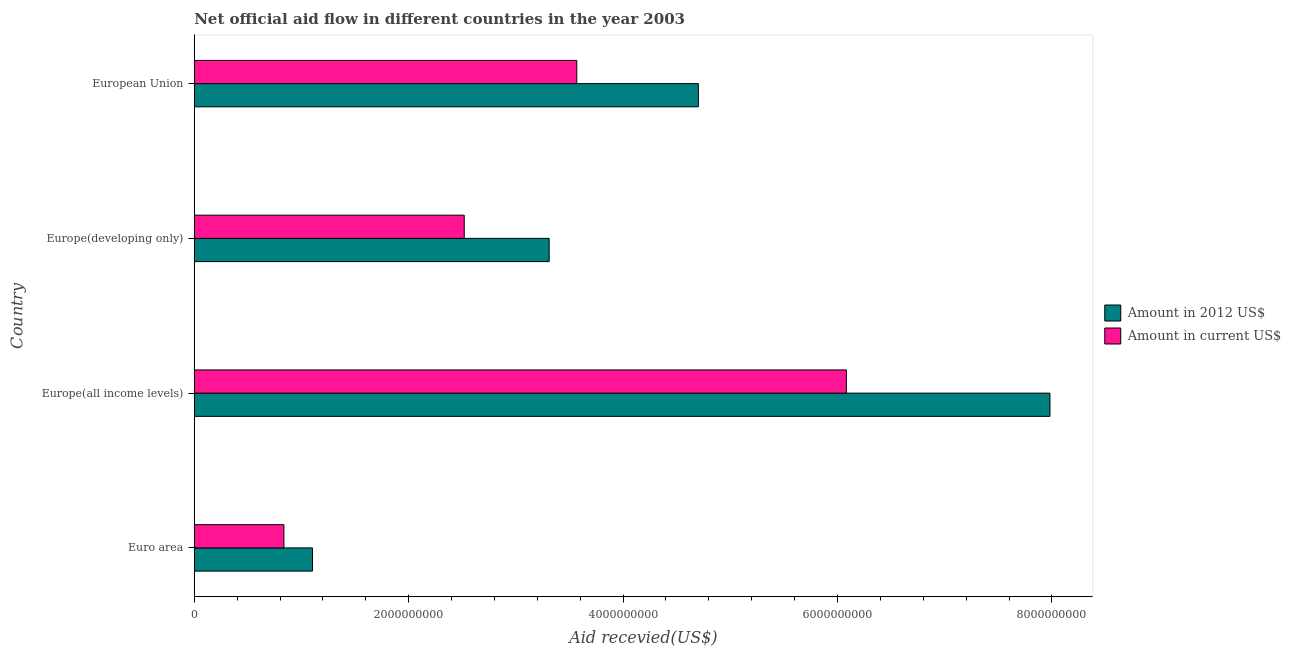How many bars are there on the 1st tick from the top?
Ensure brevity in your answer.  2. What is the label of the 3rd group of bars from the top?
Your answer should be very brief. Europe(all income levels). In how many cases, is the number of bars for a given country not equal to the number of legend labels?
Make the answer very short. 0. What is the amount of aid received(expressed in us$) in Euro area?
Your response must be concise. 8.36e+08. Across all countries, what is the maximum amount of aid received(expressed in 2012 us$)?
Your answer should be very brief. 7.98e+09. Across all countries, what is the minimum amount of aid received(expressed in 2012 us$)?
Ensure brevity in your answer.  1.10e+09. In which country was the amount of aid received(expressed in 2012 us$) maximum?
Provide a short and direct response. Europe(all income levels). In which country was the amount of aid received(expressed in 2012 us$) minimum?
Offer a very short reply. Euro area. What is the total amount of aid received(expressed in 2012 us$) in the graph?
Your answer should be very brief. 1.71e+1. What is the difference between the amount of aid received(expressed in 2012 us$) in Europe(developing only) and that in European Union?
Make the answer very short. -1.39e+09. What is the difference between the amount of aid received(expressed in us$) in Europe(all income levels) and the amount of aid received(expressed in 2012 us$) in European Union?
Ensure brevity in your answer.  1.38e+09. What is the average amount of aid received(expressed in 2012 us$) per country?
Make the answer very short. 4.27e+09. What is the difference between the amount of aid received(expressed in us$) and amount of aid received(expressed in 2012 us$) in European Union?
Provide a short and direct response. -1.13e+09. In how many countries, is the amount of aid received(expressed in 2012 us$) greater than 800000000 US$?
Provide a short and direct response. 4. What is the ratio of the amount of aid received(expressed in us$) in Europe(all income levels) to that in Europe(developing only)?
Your response must be concise. 2.42. What is the difference between the highest and the second highest amount of aid received(expressed in us$)?
Provide a succinct answer. 2.51e+09. What is the difference between the highest and the lowest amount of aid received(expressed in 2012 us$)?
Offer a very short reply. 6.88e+09. What does the 1st bar from the top in Euro area represents?
Make the answer very short. Amount in current US$. What does the 2nd bar from the bottom in Euro area represents?
Your answer should be very brief. Amount in current US$. Does the graph contain any zero values?
Offer a terse response. No. What is the title of the graph?
Ensure brevity in your answer.  Net official aid flow in different countries in the year 2003. Does "International Tourists" appear as one of the legend labels in the graph?
Your response must be concise. No. What is the label or title of the X-axis?
Your answer should be very brief. Aid recevied(US$). What is the Aid recevied(US$) in Amount in 2012 US$ in Euro area?
Your answer should be very brief. 1.10e+09. What is the Aid recevied(US$) of Amount in current US$ in Euro area?
Your answer should be very brief. 8.36e+08. What is the Aid recevied(US$) in Amount in 2012 US$ in Europe(all income levels)?
Keep it short and to the point. 7.98e+09. What is the Aid recevied(US$) of Amount in current US$ in Europe(all income levels)?
Offer a terse response. 6.08e+09. What is the Aid recevied(US$) in Amount in 2012 US$ in Europe(developing only)?
Offer a terse response. 3.31e+09. What is the Aid recevied(US$) in Amount in current US$ in Europe(developing only)?
Ensure brevity in your answer.  2.52e+09. What is the Aid recevied(US$) of Amount in 2012 US$ in European Union?
Give a very brief answer. 4.70e+09. What is the Aid recevied(US$) in Amount in current US$ in European Union?
Your answer should be compact. 3.57e+09. Across all countries, what is the maximum Aid recevied(US$) in Amount in 2012 US$?
Provide a succinct answer. 7.98e+09. Across all countries, what is the maximum Aid recevied(US$) in Amount in current US$?
Provide a succinct answer. 6.08e+09. Across all countries, what is the minimum Aid recevied(US$) of Amount in 2012 US$?
Offer a terse response. 1.10e+09. Across all countries, what is the minimum Aid recevied(US$) of Amount in current US$?
Offer a terse response. 8.36e+08. What is the total Aid recevied(US$) of Amount in 2012 US$ in the graph?
Offer a terse response. 1.71e+1. What is the total Aid recevied(US$) of Amount in current US$ in the graph?
Your answer should be very brief. 1.30e+1. What is the difference between the Aid recevied(US$) of Amount in 2012 US$ in Euro area and that in Europe(all income levels)?
Keep it short and to the point. -6.88e+09. What is the difference between the Aid recevied(US$) of Amount in current US$ in Euro area and that in Europe(all income levels)?
Your response must be concise. -5.25e+09. What is the difference between the Aid recevied(US$) of Amount in 2012 US$ in Euro area and that in Europe(developing only)?
Keep it short and to the point. -2.21e+09. What is the difference between the Aid recevied(US$) in Amount in current US$ in Euro area and that in Europe(developing only)?
Keep it short and to the point. -1.68e+09. What is the difference between the Aid recevied(US$) of Amount in 2012 US$ in Euro area and that in European Union?
Provide a succinct answer. -3.60e+09. What is the difference between the Aid recevied(US$) in Amount in current US$ in Euro area and that in European Union?
Keep it short and to the point. -2.73e+09. What is the difference between the Aid recevied(US$) of Amount in 2012 US$ in Europe(all income levels) and that in Europe(developing only)?
Make the answer very short. 4.67e+09. What is the difference between the Aid recevied(US$) in Amount in current US$ in Europe(all income levels) and that in Europe(developing only)?
Ensure brevity in your answer.  3.56e+09. What is the difference between the Aid recevied(US$) of Amount in 2012 US$ in Europe(all income levels) and that in European Union?
Offer a terse response. 3.28e+09. What is the difference between the Aid recevied(US$) of Amount in current US$ in Europe(all income levels) and that in European Union?
Offer a terse response. 2.51e+09. What is the difference between the Aid recevied(US$) in Amount in 2012 US$ in Europe(developing only) and that in European Union?
Make the answer very short. -1.39e+09. What is the difference between the Aid recevied(US$) in Amount in current US$ in Europe(developing only) and that in European Union?
Your answer should be very brief. -1.05e+09. What is the difference between the Aid recevied(US$) in Amount in 2012 US$ in Euro area and the Aid recevied(US$) in Amount in current US$ in Europe(all income levels)?
Give a very brief answer. -4.98e+09. What is the difference between the Aid recevied(US$) of Amount in 2012 US$ in Euro area and the Aid recevied(US$) of Amount in current US$ in Europe(developing only)?
Provide a short and direct response. -1.42e+09. What is the difference between the Aid recevied(US$) in Amount in 2012 US$ in Euro area and the Aid recevied(US$) in Amount in current US$ in European Union?
Ensure brevity in your answer.  -2.47e+09. What is the difference between the Aid recevied(US$) of Amount in 2012 US$ in Europe(all income levels) and the Aid recevied(US$) of Amount in current US$ in Europe(developing only)?
Provide a short and direct response. 5.46e+09. What is the difference between the Aid recevied(US$) of Amount in 2012 US$ in Europe(all income levels) and the Aid recevied(US$) of Amount in current US$ in European Union?
Your answer should be very brief. 4.41e+09. What is the difference between the Aid recevied(US$) in Amount in 2012 US$ in Europe(developing only) and the Aid recevied(US$) in Amount in current US$ in European Union?
Your response must be concise. -2.58e+08. What is the average Aid recevied(US$) of Amount in 2012 US$ per country?
Ensure brevity in your answer.  4.27e+09. What is the average Aid recevied(US$) in Amount in current US$ per country?
Your response must be concise. 3.25e+09. What is the difference between the Aid recevied(US$) in Amount in 2012 US$ and Aid recevied(US$) in Amount in current US$ in Euro area?
Offer a very short reply. 2.66e+08. What is the difference between the Aid recevied(US$) of Amount in 2012 US$ and Aid recevied(US$) of Amount in current US$ in Europe(all income levels)?
Give a very brief answer. 1.90e+09. What is the difference between the Aid recevied(US$) of Amount in 2012 US$ and Aid recevied(US$) of Amount in current US$ in Europe(developing only)?
Keep it short and to the point. 7.92e+08. What is the difference between the Aid recevied(US$) of Amount in 2012 US$ and Aid recevied(US$) of Amount in current US$ in European Union?
Offer a very short reply. 1.13e+09. What is the ratio of the Aid recevied(US$) of Amount in 2012 US$ in Euro area to that in Europe(all income levels)?
Your answer should be compact. 0.14. What is the ratio of the Aid recevied(US$) in Amount in current US$ in Euro area to that in Europe(all income levels)?
Your answer should be compact. 0.14. What is the ratio of the Aid recevied(US$) in Amount in 2012 US$ in Euro area to that in Europe(developing only)?
Provide a succinct answer. 0.33. What is the ratio of the Aid recevied(US$) in Amount in current US$ in Euro area to that in Europe(developing only)?
Make the answer very short. 0.33. What is the ratio of the Aid recevied(US$) in Amount in 2012 US$ in Euro area to that in European Union?
Your answer should be compact. 0.23. What is the ratio of the Aid recevied(US$) in Amount in current US$ in Euro area to that in European Union?
Provide a short and direct response. 0.23. What is the ratio of the Aid recevied(US$) in Amount in 2012 US$ in Europe(all income levels) to that in Europe(developing only)?
Your answer should be compact. 2.41. What is the ratio of the Aid recevied(US$) of Amount in current US$ in Europe(all income levels) to that in Europe(developing only)?
Your response must be concise. 2.42. What is the ratio of the Aid recevied(US$) in Amount in 2012 US$ in Europe(all income levels) to that in European Union?
Keep it short and to the point. 1.7. What is the ratio of the Aid recevied(US$) in Amount in current US$ in Europe(all income levels) to that in European Union?
Your response must be concise. 1.7. What is the ratio of the Aid recevied(US$) of Amount in 2012 US$ in Europe(developing only) to that in European Union?
Offer a terse response. 0.7. What is the ratio of the Aid recevied(US$) in Amount in current US$ in Europe(developing only) to that in European Union?
Provide a succinct answer. 0.71. What is the difference between the highest and the second highest Aid recevied(US$) in Amount in 2012 US$?
Ensure brevity in your answer.  3.28e+09. What is the difference between the highest and the second highest Aid recevied(US$) in Amount in current US$?
Provide a succinct answer. 2.51e+09. What is the difference between the highest and the lowest Aid recevied(US$) of Amount in 2012 US$?
Your answer should be very brief. 6.88e+09. What is the difference between the highest and the lowest Aid recevied(US$) of Amount in current US$?
Your answer should be very brief. 5.25e+09. 